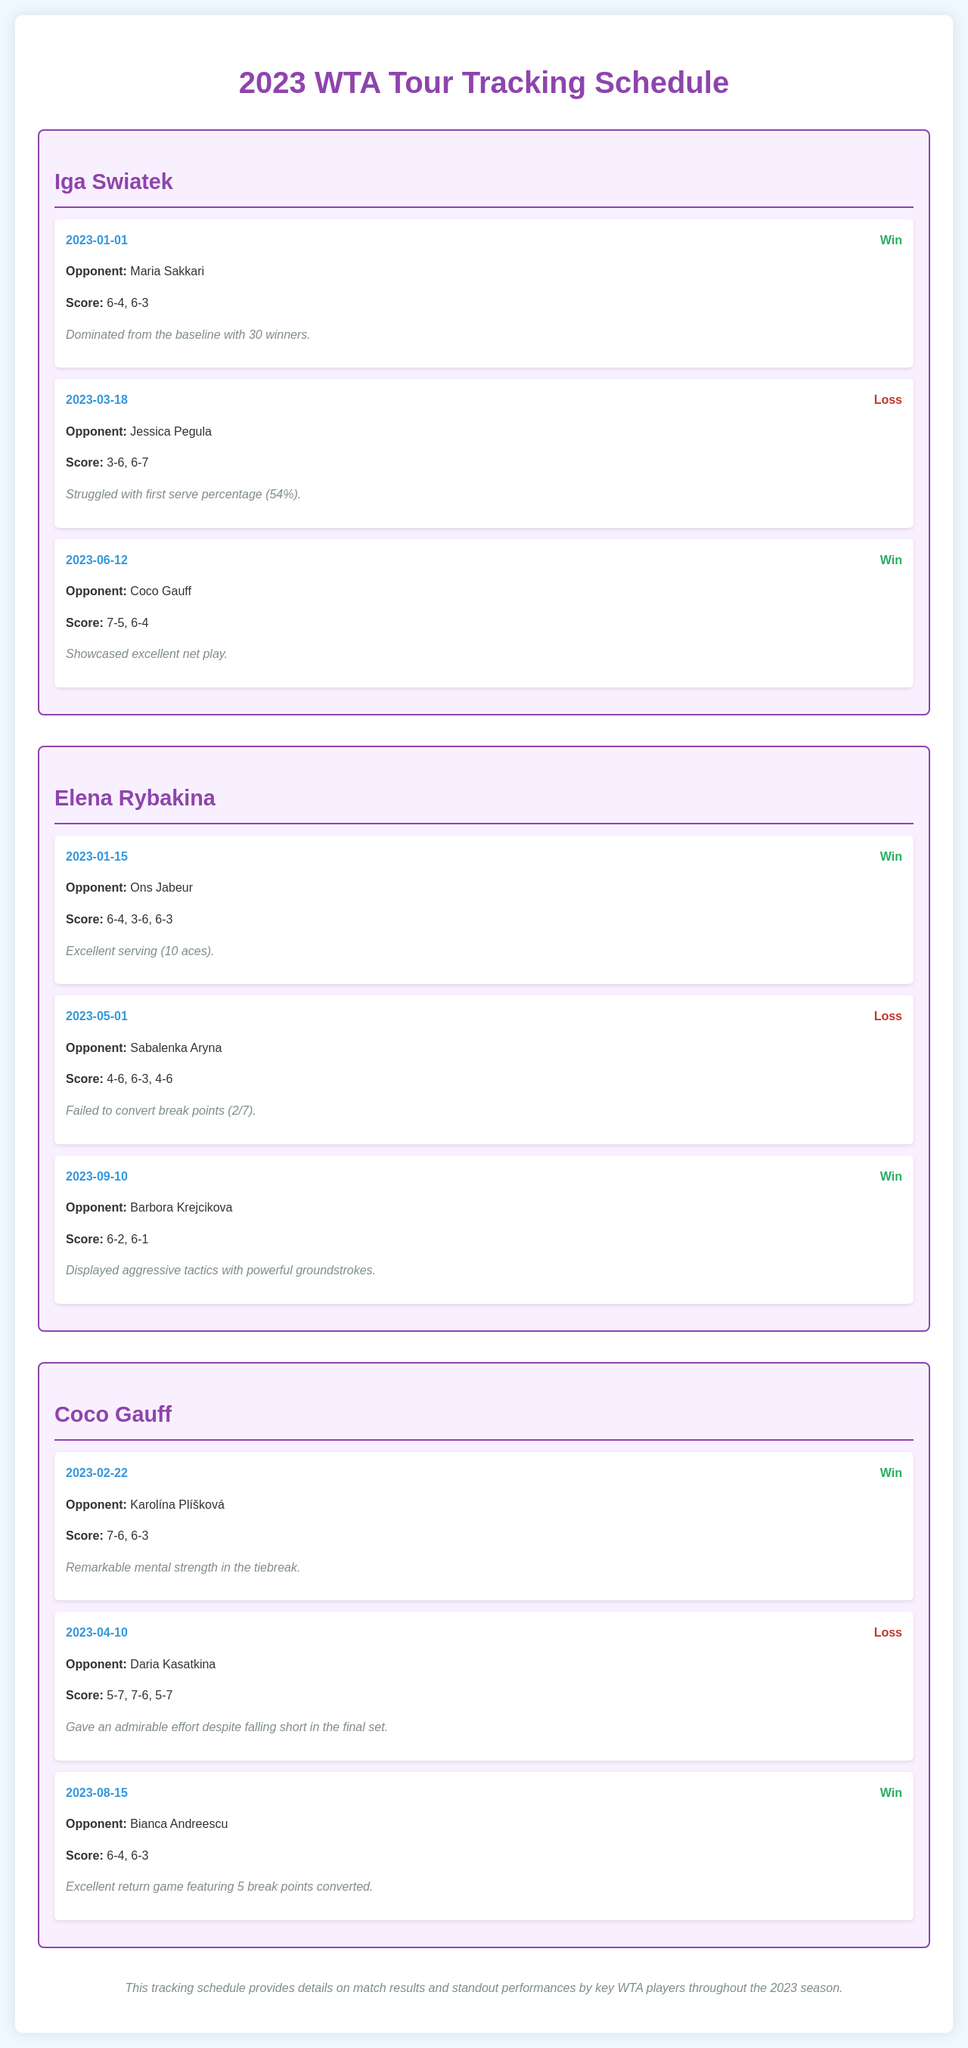what was Iga Swiatek's score against Maria Sakkari? The match score is provided under Swiatek's match against Sakkari, which is 6-4, 6-3.
Answer: 6-4, 6-3 how many aces did Elena Rybakina hit against Ons Jabeur? Rybakina's match details specifically mention that she had 10 aces against Jabeur.
Answer: 10 on what date did Coco Gauff win against Bianca Andreescu? The win against Andreescu is dated 2023-08-15 in the match details for Gauff.
Answer: 2023-08-15 who did Iga Swiatek lose to on March 18, 2023? The opponent in Swiatek's loss on that date is specified as Jessica Pegula.
Answer: Jessica Pegula how many matches did Elena Rybakina win in the provided schedule? By counting the wins listed under Rybakina’s matches, there are 2 wins mentioned.
Answer: 2 